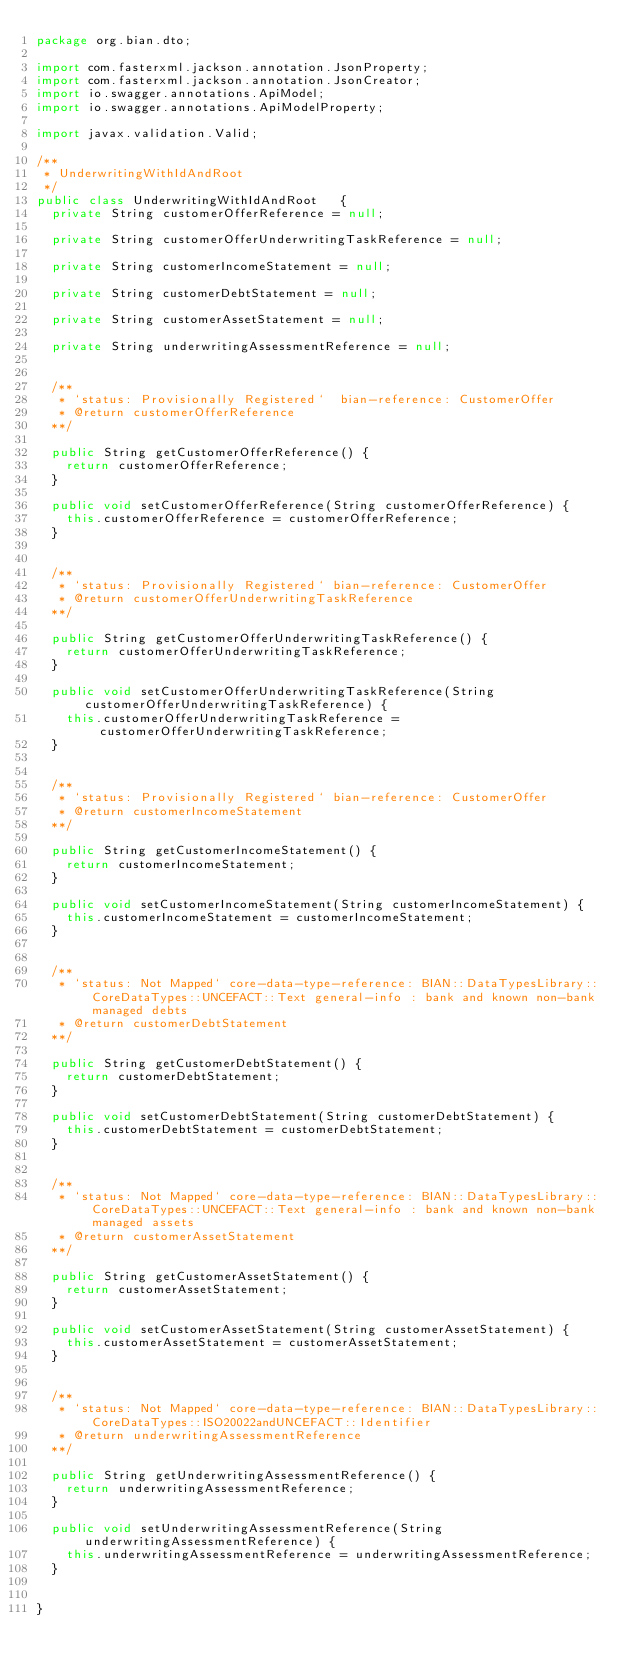Convert code to text. <code><loc_0><loc_0><loc_500><loc_500><_Java_>package org.bian.dto;

import com.fasterxml.jackson.annotation.JsonProperty;
import com.fasterxml.jackson.annotation.JsonCreator;
import io.swagger.annotations.ApiModel;
import io.swagger.annotations.ApiModelProperty;

import javax.validation.Valid;
  
/**
 * UnderwritingWithIdAndRoot
 */
public class UnderwritingWithIdAndRoot   {
  private String customerOfferReference = null;

  private String customerOfferUnderwritingTaskReference = null;

  private String customerIncomeStatement = null;

  private String customerDebtStatement = null;

  private String customerAssetStatement = null;

  private String underwritingAssessmentReference = null;


  /**
   * `status: Provisionally Registered`  bian-reference: CustomerOffer         
   * @return customerOfferReference
  **/

  public String getCustomerOfferReference() {
    return customerOfferReference;
  }

  public void setCustomerOfferReference(String customerOfferReference) {
    this.customerOfferReference = customerOfferReference;
  }


  /**
   * `status: Provisionally Registered` bian-reference: CustomerOffer       
   * @return customerOfferUnderwritingTaskReference
  **/

  public String getCustomerOfferUnderwritingTaskReference() {
    return customerOfferUnderwritingTaskReference;
  }

  public void setCustomerOfferUnderwritingTaskReference(String customerOfferUnderwritingTaskReference) {
    this.customerOfferUnderwritingTaskReference = customerOfferUnderwritingTaskReference;
  }


  /**
   * `status: Provisionally Registered` bian-reference: CustomerOffer       
   * @return customerIncomeStatement
  **/

  public String getCustomerIncomeStatement() {
    return customerIncomeStatement;
  }

  public void setCustomerIncomeStatement(String customerIncomeStatement) {
    this.customerIncomeStatement = customerIncomeStatement;
  }


  /**
   * `status: Not Mapped` core-data-type-reference: BIAN::DataTypesLibrary::CoreDataTypes::UNCEFACT::Text general-info : bank and known non-bank managed debts 
   * @return customerDebtStatement
  **/

  public String getCustomerDebtStatement() {
    return customerDebtStatement;
  }

  public void setCustomerDebtStatement(String customerDebtStatement) {
    this.customerDebtStatement = customerDebtStatement;
  }


  /**
   * `status: Not Mapped` core-data-type-reference: BIAN::DataTypesLibrary::CoreDataTypes::UNCEFACT::Text general-info : bank and known non-bank managed assets 
   * @return customerAssetStatement
  **/

  public String getCustomerAssetStatement() {
    return customerAssetStatement;
  }

  public void setCustomerAssetStatement(String customerAssetStatement) {
    this.customerAssetStatement = customerAssetStatement;
  }


  /**
   * `status: Not Mapped` core-data-type-reference: BIAN::DataTypesLibrary::CoreDataTypes::ISO20022andUNCEFACT::Identifier 
   * @return underwritingAssessmentReference
  **/

  public String getUnderwritingAssessmentReference() {
    return underwritingAssessmentReference;
  }

  public void setUnderwritingAssessmentReference(String underwritingAssessmentReference) {
    this.underwritingAssessmentReference = underwritingAssessmentReference;
  }


}

</code> 